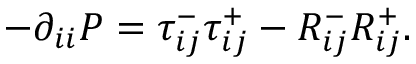<formula> <loc_0><loc_0><loc_500><loc_500>- \partial _ { i i } P = \tau _ { i j } ^ { - } \tau _ { i j } ^ { + } - R _ { i j } ^ { - } R _ { i j } ^ { + } .</formula> 